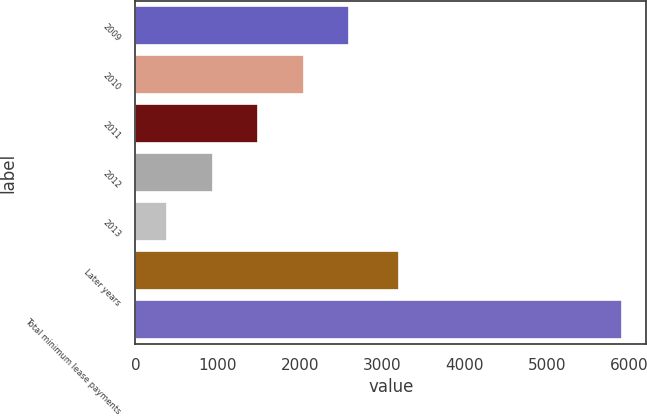<chart> <loc_0><loc_0><loc_500><loc_500><bar_chart><fcel>2009<fcel>2010<fcel>2011<fcel>2012<fcel>2013<fcel>Later years<fcel>Total minimum lease payments<nl><fcel>2597<fcel>2045<fcel>1493<fcel>941<fcel>389<fcel>3204<fcel>5909<nl></chart> 